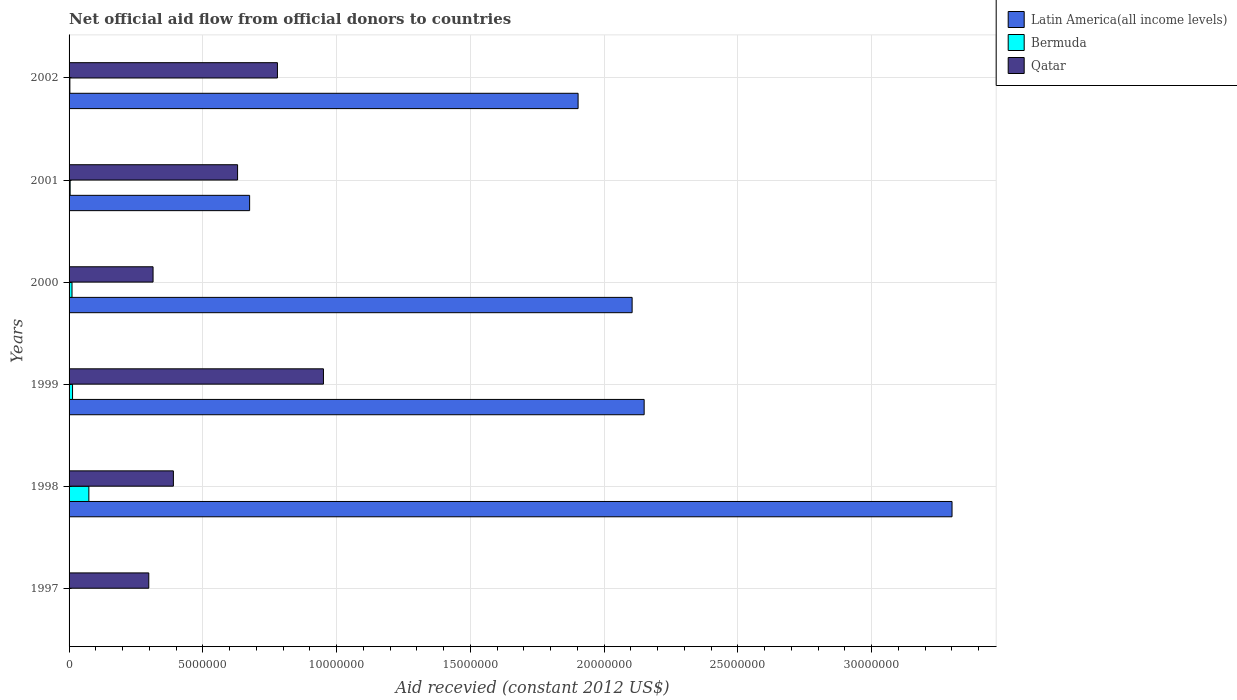How many different coloured bars are there?
Ensure brevity in your answer.  3. Are the number of bars per tick equal to the number of legend labels?
Your answer should be compact. No. Are the number of bars on each tick of the Y-axis equal?
Offer a very short reply. No. How many bars are there on the 3rd tick from the bottom?
Provide a short and direct response. 3. What is the label of the 2nd group of bars from the top?
Keep it short and to the point. 2001. What is the total aid received in Bermuda in 2002?
Your answer should be very brief. 3.00e+04. Across all years, what is the maximum total aid received in Latin America(all income levels)?
Keep it short and to the point. 3.30e+07. Across all years, what is the minimum total aid received in Qatar?
Provide a short and direct response. 2.98e+06. In which year was the total aid received in Latin America(all income levels) maximum?
Your response must be concise. 1998. What is the total total aid received in Qatar in the graph?
Provide a succinct answer. 3.36e+07. What is the difference between the total aid received in Latin America(all income levels) in 1999 and that in 2001?
Your answer should be compact. 1.48e+07. What is the average total aid received in Latin America(all income levels) per year?
Your answer should be very brief. 1.69e+07. In the year 2002, what is the difference between the total aid received in Latin America(all income levels) and total aid received in Qatar?
Offer a terse response. 1.12e+07. In how many years, is the total aid received in Latin America(all income levels) greater than 6000000 US$?
Your answer should be compact. 5. What is the ratio of the total aid received in Latin America(all income levels) in 2000 to that in 2002?
Give a very brief answer. 1.11. Is the difference between the total aid received in Latin America(all income levels) in 1999 and 2002 greater than the difference between the total aid received in Qatar in 1999 and 2002?
Give a very brief answer. Yes. What is the difference between the highest and the second highest total aid received in Qatar?
Ensure brevity in your answer.  1.72e+06. What is the difference between the highest and the lowest total aid received in Bermuda?
Make the answer very short. 7.40e+05. Is the sum of the total aid received in Qatar in 1997 and 1999 greater than the maximum total aid received in Latin America(all income levels) across all years?
Your answer should be very brief. No. Is it the case that in every year, the sum of the total aid received in Latin America(all income levels) and total aid received in Qatar is greater than the total aid received in Bermuda?
Offer a terse response. Yes. Are all the bars in the graph horizontal?
Your response must be concise. Yes. How many years are there in the graph?
Your answer should be very brief. 6. What is the difference between two consecutive major ticks on the X-axis?
Offer a very short reply. 5.00e+06. Are the values on the major ticks of X-axis written in scientific E-notation?
Offer a terse response. No. How many legend labels are there?
Offer a terse response. 3. What is the title of the graph?
Your response must be concise. Net official aid flow from official donors to countries. What is the label or title of the X-axis?
Provide a succinct answer. Aid recevied (constant 2012 US$). What is the Aid recevied (constant 2012 US$) of Bermuda in 1997?
Offer a terse response. 0. What is the Aid recevied (constant 2012 US$) of Qatar in 1997?
Your response must be concise. 2.98e+06. What is the Aid recevied (constant 2012 US$) of Latin America(all income levels) in 1998?
Your answer should be very brief. 3.30e+07. What is the Aid recevied (constant 2012 US$) of Bermuda in 1998?
Your response must be concise. 7.40e+05. What is the Aid recevied (constant 2012 US$) of Qatar in 1998?
Provide a short and direct response. 3.90e+06. What is the Aid recevied (constant 2012 US$) of Latin America(all income levels) in 1999?
Offer a terse response. 2.15e+07. What is the Aid recevied (constant 2012 US$) in Bermuda in 1999?
Your response must be concise. 1.30e+05. What is the Aid recevied (constant 2012 US$) of Qatar in 1999?
Offer a very short reply. 9.51e+06. What is the Aid recevied (constant 2012 US$) of Latin America(all income levels) in 2000?
Your answer should be very brief. 2.10e+07. What is the Aid recevied (constant 2012 US$) of Bermuda in 2000?
Give a very brief answer. 1.10e+05. What is the Aid recevied (constant 2012 US$) of Qatar in 2000?
Keep it short and to the point. 3.14e+06. What is the Aid recevied (constant 2012 US$) in Latin America(all income levels) in 2001?
Your response must be concise. 6.75e+06. What is the Aid recevied (constant 2012 US$) in Bermuda in 2001?
Offer a very short reply. 4.00e+04. What is the Aid recevied (constant 2012 US$) in Qatar in 2001?
Ensure brevity in your answer.  6.30e+06. What is the Aid recevied (constant 2012 US$) of Latin America(all income levels) in 2002?
Provide a short and direct response. 1.90e+07. What is the Aid recevied (constant 2012 US$) in Bermuda in 2002?
Make the answer very short. 3.00e+04. What is the Aid recevied (constant 2012 US$) of Qatar in 2002?
Your response must be concise. 7.79e+06. Across all years, what is the maximum Aid recevied (constant 2012 US$) in Latin America(all income levels)?
Give a very brief answer. 3.30e+07. Across all years, what is the maximum Aid recevied (constant 2012 US$) in Bermuda?
Provide a succinct answer. 7.40e+05. Across all years, what is the maximum Aid recevied (constant 2012 US$) of Qatar?
Your response must be concise. 9.51e+06. Across all years, what is the minimum Aid recevied (constant 2012 US$) of Qatar?
Your answer should be compact. 2.98e+06. What is the total Aid recevied (constant 2012 US$) in Latin America(all income levels) in the graph?
Offer a terse response. 1.01e+08. What is the total Aid recevied (constant 2012 US$) of Bermuda in the graph?
Offer a terse response. 1.05e+06. What is the total Aid recevied (constant 2012 US$) of Qatar in the graph?
Offer a terse response. 3.36e+07. What is the difference between the Aid recevied (constant 2012 US$) of Qatar in 1997 and that in 1998?
Your answer should be compact. -9.20e+05. What is the difference between the Aid recevied (constant 2012 US$) in Qatar in 1997 and that in 1999?
Your answer should be very brief. -6.53e+06. What is the difference between the Aid recevied (constant 2012 US$) of Qatar in 1997 and that in 2001?
Offer a very short reply. -3.32e+06. What is the difference between the Aid recevied (constant 2012 US$) of Qatar in 1997 and that in 2002?
Keep it short and to the point. -4.81e+06. What is the difference between the Aid recevied (constant 2012 US$) in Latin America(all income levels) in 1998 and that in 1999?
Your response must be concise. 1.15e+07. What is the difference between the Aid recevied (constant 2012 US$) of Bermuda in 1998 and that in 1999?
Give a very brief answer. 6.10e+05. What is the difference between the Aid recevied (constant 2012 US$) in Qatar in 1998 and that in 1999?
Offer a very short reply. -5.61e+06. What is the difference between the Aid recevied (constant 2012 US$) in Latin America(all income levels) in 1998 and that in 2000?
Ensure brevity in your answer.  1.20e+07. What is the difference between the Aid recevied (constant 2012 US$) in Bermuda in 1998 and that in 2000?
Make the answer very short. 6.30e+05. What is the difference between the Aid recevied (constant 2012 US$) of Qatar in 1998 and that in 2000?
Keep it short and to the point. 7.60e+05. What is the difference between the Aid recevied (constant 2012 US$) in Latin America(all income levels) in 1998 and that in 2001?
Your answer should be very brief. 2.63e+07. What is the difference between the Aid recevied (constant 2012 US$) of Bermuda in 1998 and that in 2001?
Offer a terse response. 7.00e+05. What is the difference between the Aid recevied (constant 2012 US$) in Qatar in 1998 and that in 2001?
Provide a succinct answer. -2.40e+06. What is the difference between the Aid recevied (constant 2012 US$) of Latin America(all income levels) in 1998 and that in 2002?
Ensure brevity in your answer.  1.40e+07. What is the difference between the Aid recevied (constant 2012 US$) of Bermuda in 1998 and that in 2002?
Your response must be concise. 7.10e+05. What is the difference between the Aid recevied (constant 2012 US$) of Qatar in 1998 and that in 2002?
Provide a short and direct response. -3.89e+06. What is the difference between the Aid recevied (constant 2012 US$) in Latin America(all income levels) in 1999 and that in 2000?
Keep it short and to the point. 4.50e+05. What is the difference between the Aid recevied (constant 2012 US$) in Qatar in 1999 and that in 2000?
Your answer should be very brief. 6.37e+06. What is the difference between the Aid recevied (constant 2012 US$) in Latin America(all income levels) in 1999 and that in 2001?
Make the answer very short. 1.48e+07. What is the difference between the Aid recevied (constant 2012 US$) of Bermuda in 1999 and that in 2001?
Keep it short and to the point. 9.00e+04. What is the difference between the Aid recevied (constant 2012 US$) of Qatar in 1999 and that in 2001?
Give a very brief answer. 3.21e+06. What is the difference between the Aid recevied (constant 2012 US$) in Latin America(all income levels) in 1999 and that in 2002?
Offer a terse response. 2.47e+06. What is the difference between the Aid recevied (constant 2012 US$) of Bermuda in 1999 and that in 2002?
Make the answer very short. 1.00e+05. What is the difference between the Aid recevied (constant 2012 US$) in Qatar in 1999 and that in 2002?
Your answer should be compact. 1.72e+06. What is the difference between the Aid recevied (constant 2012 US$) of Latin America(all income levels) in 2000 and that in 2001?
Your response must be concise. 1.43e+07. What is the difference between the Aid recevied (constant 2012 US$) in Qatar in 2000 and that in 2001?
Give a very brief answer. -3.16e+06. What is the difference between the Aid recevied (constant 2012 US$) of Latin America(all income levels) in 2000 and that in 2002?
Provide a succinct answer. 2.02e+06. What is the difference between the Aid recevied (constant 2012 US$) in Bermuda in 2000 and that in 2002?
Offer a very short reply. 8.00e+04. What is the difference between the Aid recevied (constant 2012 US$) of Qatar in 2000 and that in 2002?
Your answer should be very brief. -4.65e+06. What is the difference between the Aid recevied (constant 2012 US$) of Latin America(all income levels) in 2001 and that in 2002?
Make the answer very short. -1.23e+07. What is the difference between the Aid recevied (constant 2012 US$) of Bermuda in 2001 and that in 2002?
Provide a short and direct response. 10000. What is the difference between the Aid recevied (constant 2012 US$) of Qatar in 2001 and that in 2002?
Offer a terse response. -1.49e+06. What is the difference between the Aid recevied (constant 2012 US$) of Latin America(all income levels) in 1998 and the Aid recevied (constant 2012 US$) of Bermuda in 1999?
Give a very brief answer. 3.29e+07. What is the difference between the Aid recevied (constant 2012 US$) in Latin America(all income levels) in 1998 and the Aid recevied (constant 2012 US$) in Qatar in 1999?
Keep it short and to the point. 2.35e+07. What is the difference between the Aid recevied (constant 2012 US$) in Bermuda in 1998 and the Aid recevied (constant 2012 US$) in Qatar in 1999?
Give a very brief answer. -8.77e+06. What is the difference between the Aid recevied (constant 2012 US$) of Latin America(all income levels) in 1998 and the Aid recevied (constant 2012 US$) of Bermuda in 2000?
Offer a terse response. 3.29e+07. What is the difference between the Aid recevied (constant 2012 US$) in Latin America(all income levels) in 1998 and the Aid recevied (constant 2012 US$) in Qatar in 2000?
Your answer should be compact. 2.99e+07. What is the difference between the Aid recevied (constant 2012 US$) of Bermuda in 1998 and the Aid recevied (constant 2012 US$) of Qatar in 2000?
Your response must be concise. -2.40e+06. What is the difference between the Aid recevied (constant 2012 US$) in Latin America(all income levels) in 1998 and the Aid recevied (constant 2012 US$) in Bermuda in 2001?
Offer a terse response. 3.30e+07. What is the difference between the Aid recevied (constant 2012 US$) of Latin America(all income levels) in 1998 and the Aid recevied (constant 2012 US$) of Qatar in 2001?
Your answer should be very brief. 2.67e+07. What is the difference between the Aid recevied (constant 2012 US$) in Bermuda in 1998 and the Aid recevied (constant 2012 US$) in Qatar in 2001?
Your response must be concise. -5.56e+06. What is the difference between the Aid recevied (constant 2012 US$) of Latin America(all income levels) in 1998 and the Aid recevied (constant 2012 US$) of Bermuda in 2002?
Provide a short and direct response. 3.30e+07. What is the difference between the Aid recevied (constant 2012 US$) in Latin America(all income levels) in 1998 and the Aid recevied (constant 2012 US$) in Qatar in 2002?
Offer a very short reply. 2.52e+07. What is the difference between the Aid recevied (constant 2012 US$) in Bermuda in 1998 and the Aid recevied (constant 2012 US$) in Qatar in 2002?
Your answer should be compact. -7.05e+06. What is the difference between the Aid recevied (constant 2012 US$) in Latin America(all income levels) in 1999 and the Aid recevied (constant 2012 US$) in Bermuda in 2000?
Your response must be concise. 2.14e+07. What is the difference between the Aid recevied (constant 2012 US$) of Latin America(all income levels) in 1999 and the Aid recevied (constant 2012 US$) of Qatar in 2000?
Offer a terse response. 1.84e+07. What is the difference between the Aid recevied (constant 2012 US$) of Bermuda in 1999 and the Aid recevied (constant 2012 US$) of Qatar in 2000?
Your response must be concise. -3.01e+06. What is the difference between the Aid recevied (constant 2012 US$) in Latin America(all income levels) in 1999 and the Aid recevied (constant 2012 US$) in Bermuda in 2001?
Your answer should be compact. 2.15e+07. What is the difference between the Aid recevied (constant 2012 US$) of Latin America(all income levels) in 1999 and the Aid recevied (constant 2012 US$) of Qatar in 2001?
Keep it short and to the point. 1.52e+07. What is the difference between the Aid recevied (constant 2012 US$) of Bermuda in 1999 and the Aid recevied (constant 2012 US$) of Qatar in 2001?
Provide a succinct answer. -6.17e+06. What is the difference between the Aid recevied (constant 2012 US$) of Latin America(all income levels) in 1999 and the Aid recevied (constant 2012 US$) of Bermuda in 2002?
Give a very brief answer. 2.15e+07. What is the difference between the Aid recevied (constant 2012 US$) of Latin America(all income levels) in 1999 and the Aid recevied (constant 2012 US$) of Qatar in 2002?
Make the answer very short. 1.37e+07. What is the difference between the Aid recevied (constant 2012 US$) of Bermuda in 1999 and the Aid recevied (constant 2012 US$) of Qatar in 2002?
Offer a very short reply. -7.66e+06. What is the difference between the Aid recevied (constant 2012 US$) in Latin America(all income levels) in 2000 and the Aid recevied (constant 2012 US$) in Bermuda in 2001?
Make the answer very short. 2.10e+07. What is the difference between the Aid recevied (constant 2012 US$) of Latin America(all income levels) in 2000 and the Aid recevied (constant 2012 US$) of Qatar in 2001?
Make the answer very short. 1.48e+07. What is the difference between the Aid recevied (constant 2012 US$) in Bermuda in 2000 and the Aid recevied (constant 2012 US$) in Qatar in 2001?
Keep it short and to the point. -6.19e+06. What is the difference between the Aid recevied (constant 2012 US$) of Latin America(all income levels) in 2000 and the Aid recevied (constant 2012 US$) of Bermuda in 2002?
Make the answer very short. 2.10e+07. What is the difference between the Aid recevied (constant 2012 US$) in Latin America(all income levels) in 2000 and the Aid recevied (constant 2012 US$) in Qatar in 2002?
Keep it short and to the point. 1.33e+07. What is the difference between the Aid recevied (constant 2012 US$) of Bermuda in 2000 and the Aid recevied (constant 2012 US$) of Qatar in 2002?
Offer a very short reply. -7.68e+06. What is the difference between the Aid recevied (constant 2012 US$) in Latin America(all income levels) in 2001 and the Aid recevied (constant 2012 US$) in Bermuda in 2002?
Keep it short and to the point. 6.72e+06. What is the difference between the Aid recevied (constant 2012 US$) in Latin America(all income levels) in 2001 and the Aid recevied (constant 2012 US$) in Qatar in 2002?
Offer a terse response. -1.04e+06. What is the difference between the Aid recevied (constant 2012 US$) of Bermuda in 2001 and the Aid recevied (constant 2012 US$) of Qatar in 2002?
Offer a very short reply. -7.75e+06. What is the average Aid recevied (constant 2012 US$) of Latin America(all income levels) per year?
Make the answer very short. 1.69e+07. What is the average Aid recevied (constant 2012 US$) in Bermuda per year?
Make the answer very short. 1.75e+05. What is the average Aid recevied (constant 2012 US$) of Qatar per year?
Your answer should be very brief. 5.60e+06. In the year 1998, what is the difference between the Aid recevied (constant 2012 US$) in Latin America(all income levels) and Aid recevied (constant 2012 US$) in Bermuda?
Provide a succinct answer. 3.23e+07. In the year 1998, what is the difference between the Aid recevied (constant 2012 US$) in Latin America(all income levels) and Aid recevied (constant 2012 US$) in Qatar?
Your response must be concise. 2.91e+07. In the year 1998, what is the difference between the Aid recevied (constant 2012 US$) of Bermuda and Aid recevied (constant 2012 US$) of Qatar?
Your answer should be compact. -3.16e+06. In the year 1999, what is the difference between the Aid recevied (constant 2012 US$) of Latin America(all income levels) and Aid recevied (constant 2012 US$) of Bermuda?
Ensure brevity in your answer.  2.14e+07. In the year 1999, what is the difference between the Aid recevied (constant 2012 US$) in Latin America(all income levels) and Aid recevied (constant 2012 US$) in Qatar?
Make the answer very short. 1.20e+07. In the year 1999, what is the difference between the Aid recevied (constant 2012 US$) in Bermuda and Aid recevied (constant 2012 US$) in Qatar?
Your answer should be very brief. -9.38e+06. In the year 2000, what is the difference between the Aid recevied (constant 2012 US$) of Latin America(all income levels) and Aid recevied (constant 2012 US$) of Bermuda?
Provide a succinct answer. 2.09e+07. In the year 2000, what is the difference between the Aid recevied (constant 2012 US$) of Latin America(all income levels) and Aid recevied (constant 2012 US$) of Qatar?
Ensure brevity in your answer.  1.79e+07. In the year 2000, what is the difference between the Aid recevied (constant 2012 US$) of Bermuda and Aid recevied (constant 2012 US$) of Qatar?
Offer a terse response. -3.03e+06. In the year 2001, what is the difference between the Aid recevied (constant 2012 US$) in Latin America(all income levels) and Aid recevied (constant 2012 US$) in Bermuda?
Your response must be concise. 6.71e+06. In the year 2001, what is the difference between the Aid recevied (constant 2012 US$) in Bermuda and Aid recevied (constant 2012 US$) in Qatar?
Offer a very short reply. -6.26e+06. In the year 2002, what is the difference between the Aid recevied (constant 2012 US$) in Latin America(all income levels) and Aid recevied (constant 2012 US$) in Bermuda?
Offer a very short reply. 1.90e+07. In the year 2002, what is the difference between the Aid recevied (constant 2012 US$) of Latin America(all income levels) and Aid recevied (constant 2012 US$) of Qatar?
Give a very brief answer. 1.12e+07. In the year 2002, what is the difference between the Aid recevied (constant 2012 US$) of Bermuda and Aid recevied (constant 2012 US$) of Qatar?
Ensure brevity in your answer.  -7.76e+06. What is the ratio of the Aid recevied (constant 2012 US$) in Qatar in 1997 to that in 1998?
Give a very brief answer. 0.76. What is the ratio of the Aid recevied (constant 2012 US$) in Qatar in 1997 to that in 1999?
Ensure brevity in your answer.  0.31. What is the ratio of the Aid recevied (constant 2012 US$) of Qatar in 1997 to that in 2000?
Ensure brevity in your answer.  0.95. What is the ratio of the Aid recevied (constant 2012 US$) of Qatar in 1997 to that in 2001?
Ensure brevity in your answer.  0.47. What is the ratio of the Aid recevied (constant 2012 US$) of Qatar in 1997 to that in 2002?
Provide a succinct answer. 0.38. What is the ratio of the Aid recevied (constant 2012 US$) in Latin America(all income levels) in 1998 to that in 1999?
Offer a very short reply. 1.54. What is the ratio of the Aid recevied (constant 2012 US$) of Bermuda in 1998 to that in 1999?
Your answer should be compact. 5.69. What is the ratio of the Aid recevied (constant 2012 US$) in Qatar in 1998 to that in 1999?
Provide a succinct answer. 0.41. What is the ratio of the Aid recevied (constant 2012 US$) in Latin America(all income levels) in 1998 to that in 2000?
Your response must be concise. 1.57. What is the ratio of the Aid recevied (constant 2012 US$) in Bermuda in 1998 to that in 2000?
Ensure brevity in your answer.  6.73. What is the ratio of the Aid recevied (constant 2012 US$) of Qatar in 1998 to that in 2000?
Offer a terse response. 1.24. What is the ratio of the Aid recevied (constant 2012 US$) in Latin America(all income levels) in 1998 to that in 2001?
Provide a succinct answer. 4.89. What is the ratio of the Aid recevied (constant 2012 US$) in Qatar in 1998 to that in 2001?
Offer a terse response. 0.62. What is the ratio of the Aid recevied (constant 2012 US$) in Latin America(all income levels) in 1998 to that in 2002?
Give a very brief answer. 1.73. What is the ratio of the Aid recevied (constant 2012 US$) of Bermuda in 1998 to that in 2002?
Offer a terse response. 24.67. What is the ratio of the Aid recevied (constant 2012 US$) of Qatar in 1998 to that in 2002?
Provide a succinct answer. 0.5. What is the ratio of the Aid recevied (constant 2012 US$) in Latin America(all income levels) in 1999 to that in 2000?
Provide a short and direct response. 1.02. What is the ratio of the Aid recevied (constant 2012 US$) of Bermuda in 1999 to that in 2000?
Offer a very short reply. 1.18. What is the ratio of the Aid recevied (constant 2012 US$) of Qatar in 1999 to that in 2000?
Provide a short and direct response. 3.03. What is the ratio of the Aid recevied (constant 2012 US$) of Latin America(all income levels) in 1999 to that in 2001?
Your answer should be very brief. 3.19. What is the ratio of the Aid recevied (constant 2012 US$) in Qatar in 1999 to that in 2001?
Your response must be concise. 1.51. What is the ratio of the Aid recevied (constant 2012 US$) in Latin America(all income levels) in 1999 to that in 2002?
Ensure brevity in your answer.  1.13. What is the ratio of the Aid recevied (constant 2012 US$) of Bermuda in 1999 to that in 2002?
Offer a very short reply. 4.33. What is the ratio of the Aid recevied (constant 2012 US$) of Qatar in 1999 to that in 2002?
Offer a terse response. 1.22. What is the ratio of the Aid recevied (constant 2012 US$) in Latin America(all income levels) in 2000 to that in 2001?
Make the answer very short. 3.12. What is the ratio of the Aid recevied (constant 2012 US$) of Bermuda in 2000 to that in 2001?
Keep it short and to the point. 2.75. What is the ratio of the Aid recevied (constant 2012 US$) in Qatar in 2000 to that in 2001?
Your answer should be compact. 0.5. What is the ratio of the Aid recevied (constant 2012 US$) in Latin America(all income levels) in 2000 to that in 2002?
Ensure brevity in your answer.  1.11. What is the ratio of the Aid recevied (constant 2012 US$) of Bermuda in 2000 to that in 2002?
Provide a short and direct response. 3.67. What is the ratio of the Aid recevied (constant 2012 US$) of Qatar in 2000 to that in 2002?
Ensure brevity in your answer.  0.4. What is the ratio of the Aid recevied (constant 2012 US$) of Latin America(all income levels) in 2001 to that in 2002?
Your answer should be compact. 0.35. What is the ratio of the Aid recevied (constant 2012 US$) in Qatar in 2001 to that in 2002?
Offer a terse response. 0.81. What is the difference between the highest and the second highest Aid recevied (constant 2012 US$) in Latin America(all income levels)?
Offer a terse response. 1.15e+07. What is the difference between the highest and the second highest Aid recevied (constant 2012 US$) in Bermuda?
Offer a very short reply. 6.10e+05. What is the difference between the highest and the second highest Aid recevied (constant 2012 US$) of Qatar?
Provide a short and direct response. 1.72e+06. What is the difference between the highest and the lowest Aid recevied (constant 2012 US$) in Latin America(all income levels)?
Ensure brevity in your answer.  3.30e+07. What is the difference between the highest and the lowest Aid recevied (constant 2012 US$) in Bermuda?
Offer a very short reply. 7.40e+05. What is the difference between the highest and the lowest Aid recevied (constant 2012 US$) of Qatar?
Provide a short and direct response. 6.53e+06. 